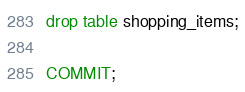<code> <loc_0><loc_0><loc_500><loc_500><_SQL_>drop table shopping_items;

COMMIT;
</code> 